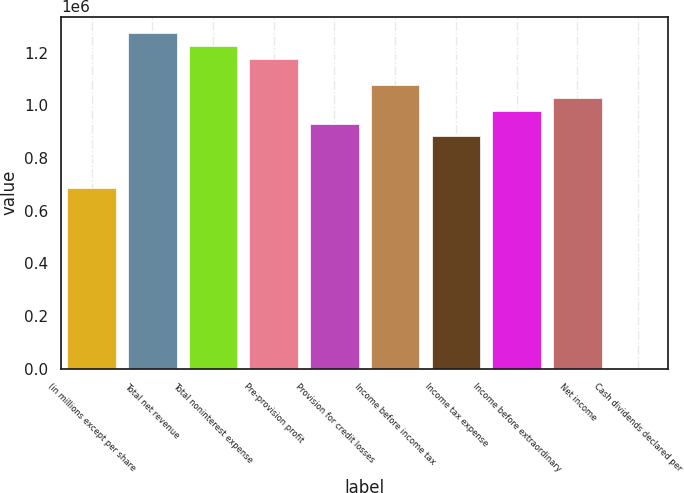Convert chart. <chart><loc_0><loc_0><loc_500><loc_500><bar_chart><fcel>(in millions except per share<fcel>Total net revenue<fcel>Total noninterest expense<fcel>Pre-provision profit<fcel>Provision for credit losses<fcel>Income before income tax<fcel>Income tax expense<fcel>Income before extraordinary<fcel>Net income<fcel>Cash dividends declared per<nl><fcel>685849<fcel>1.27372e+06<fcel>1.22473e+06<fcel>1.17574e+06<fcel>930795<fcel>1.07776e+06<fcel>881805<fcel>979784<fcel>1.02877e+06<fcel>0.2<nl></chart> 